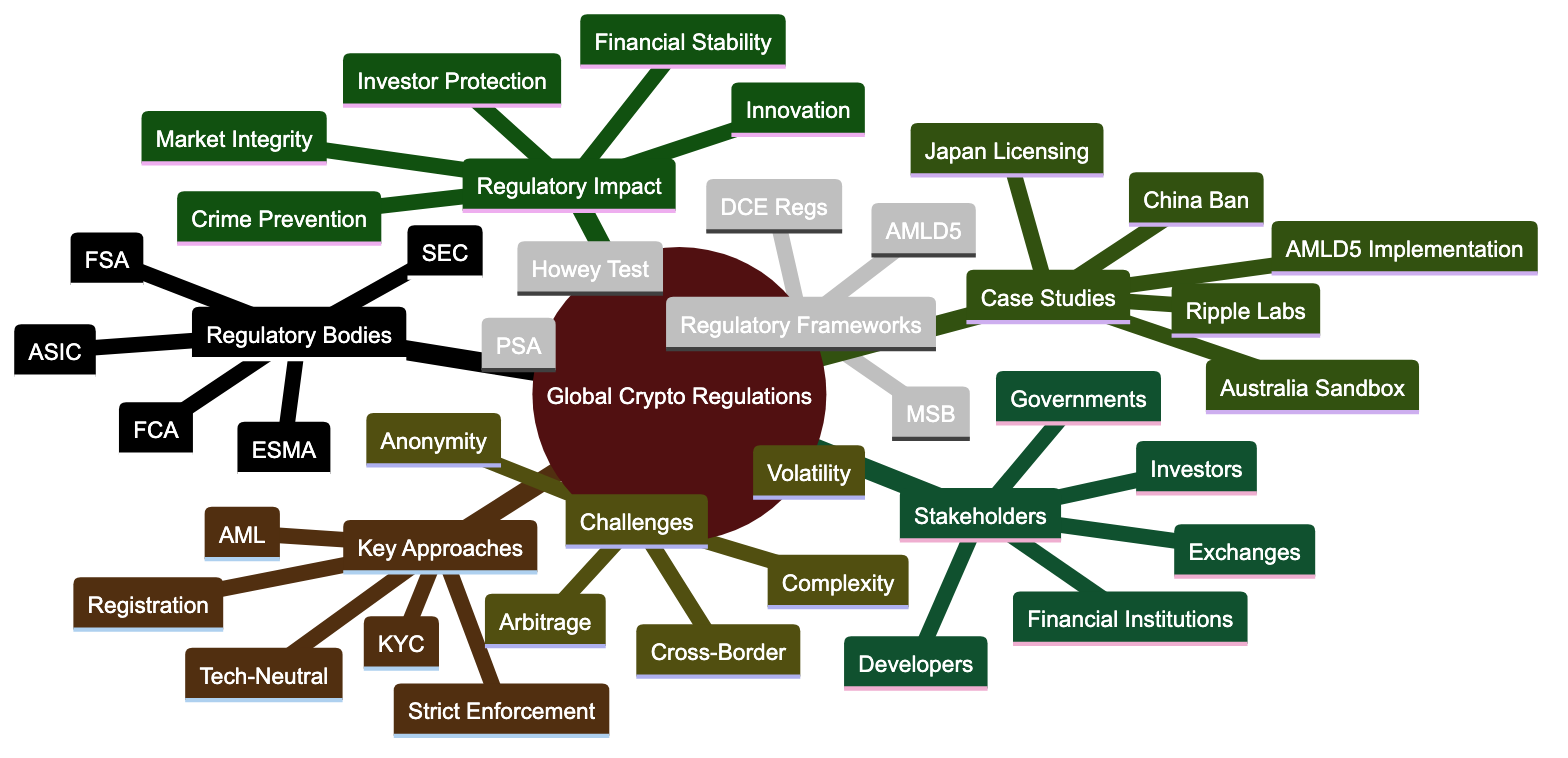What are the two key regulatory approaches listed in the diagram? Two key regulatory approaches mentioned in the diagram are "Strict Enforcement" and "Registration Requirements". By looking under the "Key Regulatory Approaches" section, I can identify these items.
Answer: Strict Enforcement, Registration Requirements How many regulatory bodies are listed? The diagram lists five regulatory bodies, found under the "Regulatory Bodies" section which includes SEC, ESMA, FCA, ASIC, and FSA. Counting these gives the total.
Answer: 5 Which case study represents a financial entity's legal action in the USA? The "USA vs. Ripple Labs" case study is specifically associated with a legal action by a financial entity in the United States. This information is available in the "Case Studies" section.
Answer: USA vs. Ripple Labs What challenge in regulation relates to geographic limitations? The challenge labeled "Cross-Border Transactions" pertains to issues that arise due to different countries’ regulations affecting cryptocurrency. This is one of the obstacles listed in the "Challenges in Regulation" section.
Answer: Cross-Border Transactions Which regulatory framework corresponds to Japan? The "Payment Services Act" is the regulatory framework associated with Japan, identified in the "Regulatory Frameworks" section.
Answer: Payment Services Act What is a common perspective shared by all stakeholders mentioned? "Financial Institutions" as a stakeholder perspective indicates a common interest in the regulatory landscape affecting cryptocurrency operations. The "Stakeholder Perspectives" section lists this as one of the five viewpoints.
Answer: Financial Institutions Name a regulatory impact related to investor security. "Protection of Investors" is a regulatory impact that directly addresses the security of individuals investing in cryptocurrencies, clearly stated in the "Regulatory Impact" section.
Answer: Protection of Investors What does KYC stand for in key regulatory approaches? KYC stands for "Know Your Customer", which is mentioned as one of the key regulatory approaches in the diagram. By locating "KYC" in the "Key Regulatory Approaches" section, I can confirm its meaning.
Answer: Know Your Customer What directive is implemented in the EU concerning anti-money laundering? The directive referenced is "5th Anti-Money Laundering Directive", which addresses regulatory frameworks within the European context as detailed in the "Regulatory Frameworks" section.
Answer: 5th Anti-Money Laundering Directive 